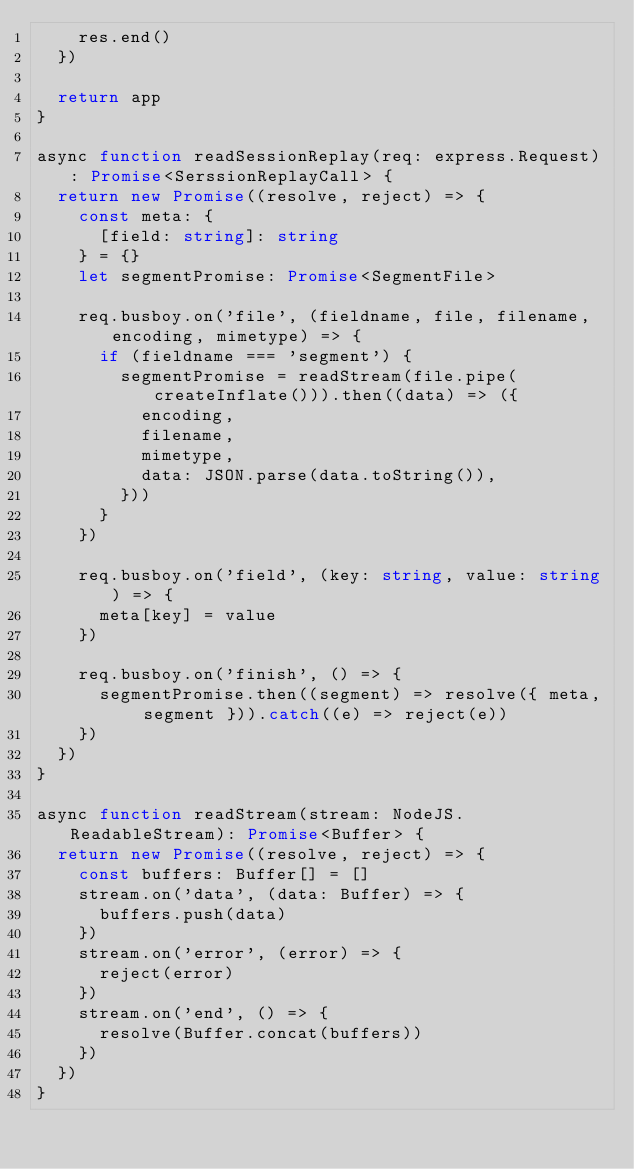Convert code to text. <code><loc_0><loc_0><loc_500><loc_500><_TypeScript_>    res.end()
  })

  return app
}

async function readSessionReplay(req: express.Request): Promise<SerssionReplayCall> {
  return new Promise((resolve, reject) => {
    const meta: {
      [field: string]: string
    } = {}
    let segmentPromise: Promise<SegmentFile>

    req.busboy.on('file', (fieldname, file, filename, encoding, mimetype) => {
      if (fieldname === 'segment') {
        segmentPromise = readStream(file.pipe(createInflate())).then((data) => ({
          encoding,
          filename,
          mimetype,
          data: JSON.parse(data.toString()),
        }))
      }
    })

    req.busboy.on('field', (key: string, value: string) => {
      meta[key] = value
    })

    req.busboy.on('finish', () => {
      segmentPromise.then((segment) => resolve({ meta, segment })).catch((e) => reject(e))
    })
  })
}

async function readStream(stream: NodeJS.ReadableStream): Promise<Buffer> {
  return new Promise((resolve, reject) => {
    const buffers: Buffer[] = []
    stream.on('data', (data: Buffer) => {
      buffers.push(data)
    })
    stream.on('error', (error) => {
      reject(error)
    })
    stream.on('end', () => {
      resolve(Buffer.concat(buffers))
    })
  })
}
</code> 